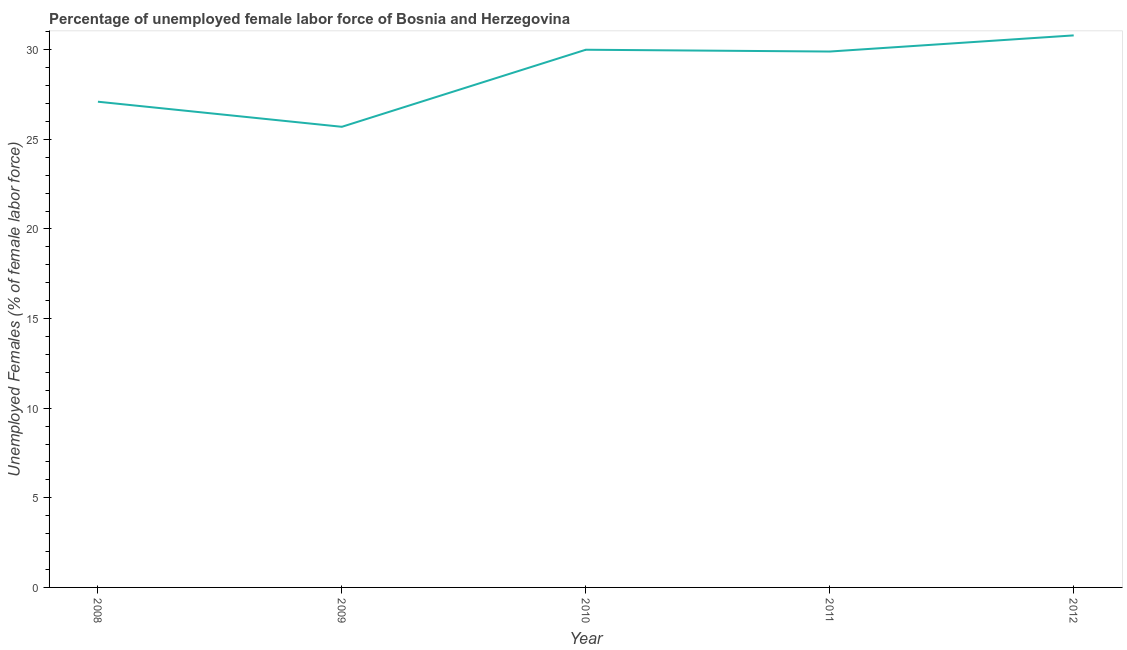What is the total unemployed female labour force in 2009?
Provide a succinct answer. 25.7. Across all years, what is the maximum total unemployed female labour force?
Your response must be concise. 30.8. Across all years, what is the minimum total unemployed female labour force?
Make the answer very short. 25.7. In which year was the total unemployed female labour force maximum?
Provide a short and direct response. 2012. What is the sum of the total unemployed female labour force?
Ensure brevity in your answer.  143.5. What is the difference between the total unemployed female labour force in 2008 and 2010?
Your response must be concise. -2.9. What is the average total unemployed female labour force per year?
Your response must be concise. 28.7. What is the median total unemployed female labour force?
Offer a terse response. 29.9. What is the ratio of the total unemployed female labour force in 2011 to that in 2012?
Ensure brevity in your answer.  0.97. What is the difference between the highest and the second highest total unemployed female labour force?
Give a very brief answer. 0.8. Is the sum of the total unemployed female labour force in 2009 and 2011 greater than the maximum total unemployed female labour force across all years?
Provide a short and direct response. Yes. What is the difference between the highest and the lowest total unemployed female labour force?
Give a very brief answer. 5.1. Does the total unemployed female labour force monotonically increase over the years?
Your answer should be very brief. No. How many years are there in the graph?
Offer a terse response. 5. Are the values on the major ticks of Y-axis written in scientific E-notation?
Your response must be concise. No. Does the graph contain grids?
Make the answer very short. No. What is the title of the graph?
Provide a short and direct response. Percentage of unemployed female labor force of Bosnia and Herzegovina. What is the label or title of the Y-axis?
Offer a terse response. Unemployed Females (% of female labor force). What is the Unemployed Females (% of female labor force) of 2008?
Your answer should be very brief. 27.1. What is the Unemployed Females (% of female labor force) of 2009?
Offer a very short reply. 25.7. What is the Unemployed Females (% of female labor force) in 2011?
Provide a succinct answer. 29.9. What is the Unemployed Females (% of female labor force) of 2012?
Provide a short and direct response. 30.8. What is the difference between the Unemployed Females (% of female labor force) in 2008 and 2009?
Make the answer very short. 1.4. What is the difference between the Unemployed Females (% of female labor force) in 2008 and 2010?
Your answer should be compact. -2.9. What is the difference between the Unemployed Females (% of female labor force) in 2008 and 2012?
Ensure brevity in your answer.  -3.7. What is the difference between the Unemployed Females (% of female labor force) in 2009 and 2010?
Provide a succinct answer. -4.3. What is the difference between the Unemployed Females (% of female labor force) in 2009 and 2012?
Offer a terse response. -5.1. What is the difference between the Unemployed Females (% of female labor force) in 2010 and 2011?
Ensure brevity in your answer.  0.1. What is the difference between the Unemployed Females (% of female labor force) in 2011 and 2012?
Your answer should be compact. -0.9. What is the ratio of the Unemployed Females (% of female labor force) in 2008 to that in 2009?
Provide a short and direct response. 1.05. What is the ratio of the Unemployed Females (% of female labor force) in 2008 to that in 2010?
Your response must be concise. 0.9. What is the ratio of the Unemployed Females (% of female labor force) in 2008 to that in 2011?
Keep it short and to the point. 0.91. What is the ratio of the Unemployed Females (% of female labor force) in 2008 to that in 2012?
Your response must be concise. 0.88. What is the ratio of the Unemployed Females (% of female labor force) in 2009 to that in 2010?
Provide a short and direct response. 0.86. What is the ratio of the Unemployed Females (% of female labor force) in 2009 to that in 2011?
Give a very brief answer. 0.86. What is the ratio of the Unemployed Females (% of female labor force) in 2009 to that in 2012?
Make the answer very short. 0.83. What is the ratio of the Unemployed Females (% of female labor force) in 2010 to that in 2012?
Your answer should be very brief. 0.97. 